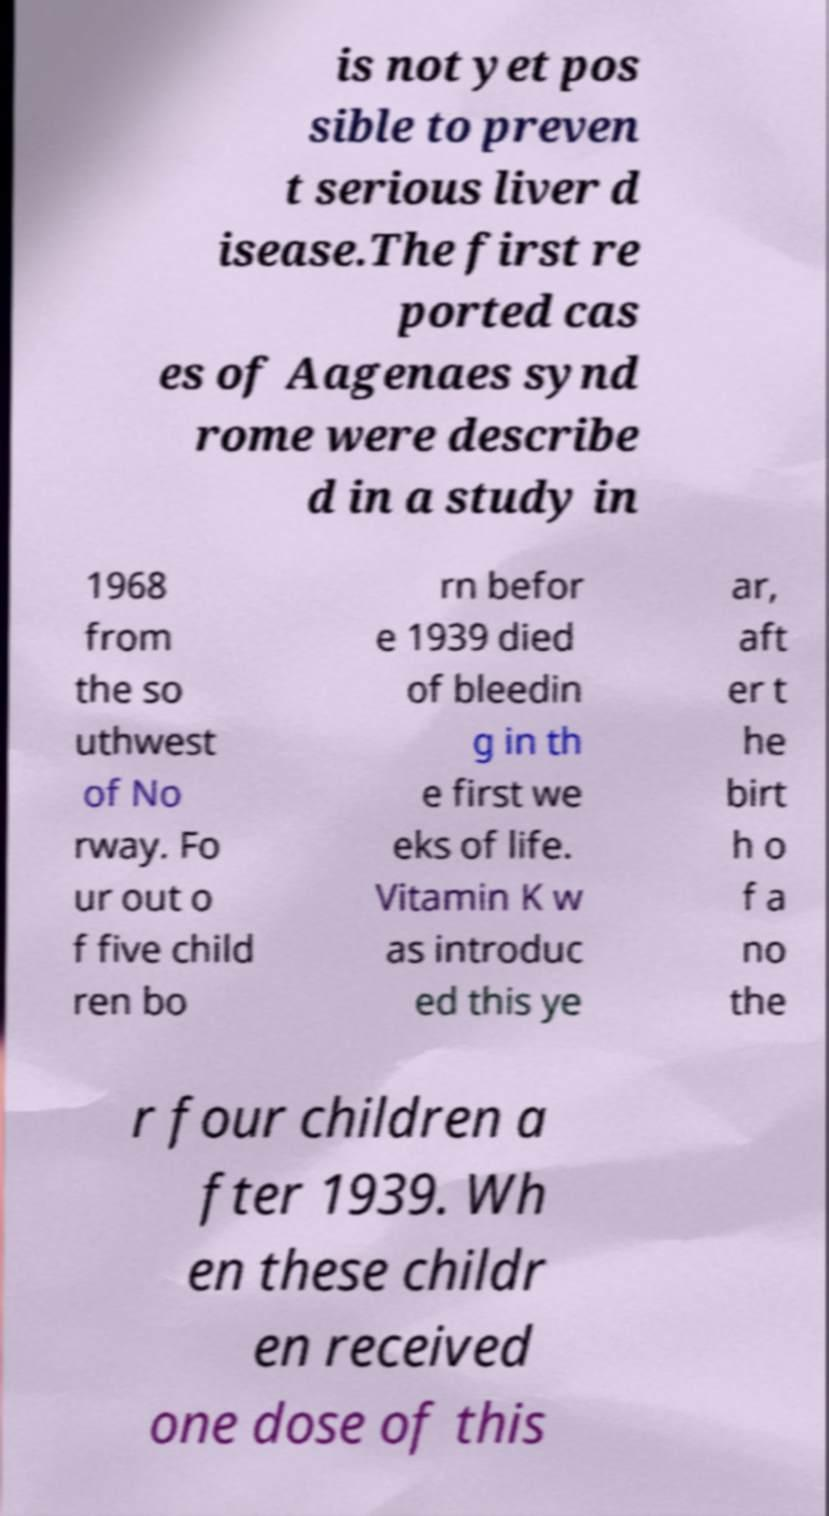Could you extract and type out the text from this image? is not yet pos sible to preven t serious liver d isease.The first re ported cas es of Aagenaes synd rome were describe d in a study in 1968 from the so uthwest of No rway. Fo ur out o f five child ren bo rn befor e 1939 died of bleedin g in th e first we eks of life. Vitamin K w as introduc ed this ye ar, aft er t he birt h o f a no the r four children a fter 1939. Wh en these childr en received one dose of this 